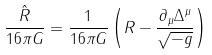Convert formula to latex. <formula><loc_0><loc_0><loc_500><loc_500>\frac { \hat { R } } { 1 6 \pi G } = \frac { 1 } { 1 6 \pi G } \left ( R - \frac { \partial _ { \mu } \Delta ^ { \mu } } { \sqrt { - g } } \right ) \</formula> 